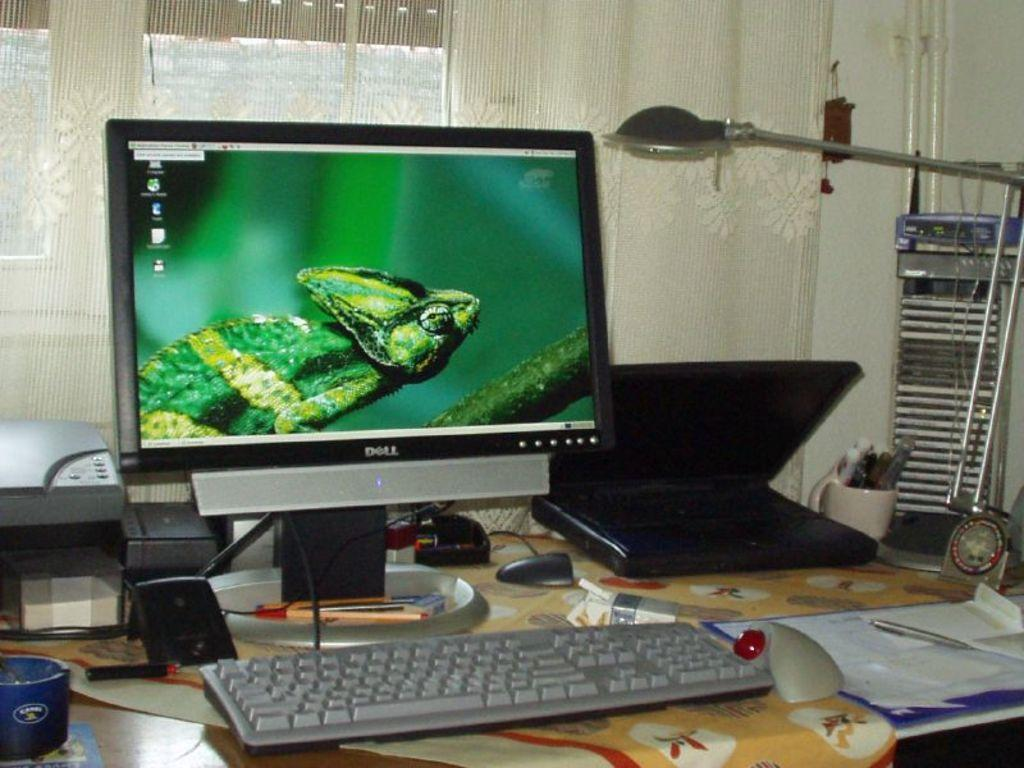<image>
Provide a brief description of the given image. A Dell computer monitor has a picture of a lizard on it. 